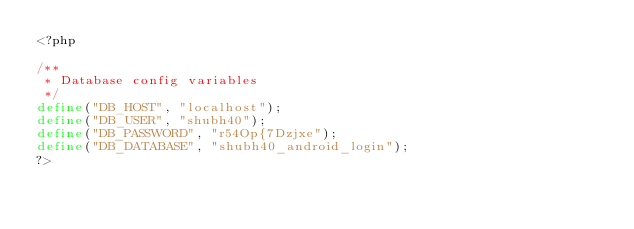<code> <loc_0><loc_0><loc_500><loc_500><_PHP_><?php

/**
 * Database config variables
 */
define("DB_HOST", "localhost");
define("DB_USER", "shubh40");
define("DB_PASSWORD", "r54Op{7Dzjxe");
define("DB_DATABASE", "shubh40_android_login");
?>
</code> 